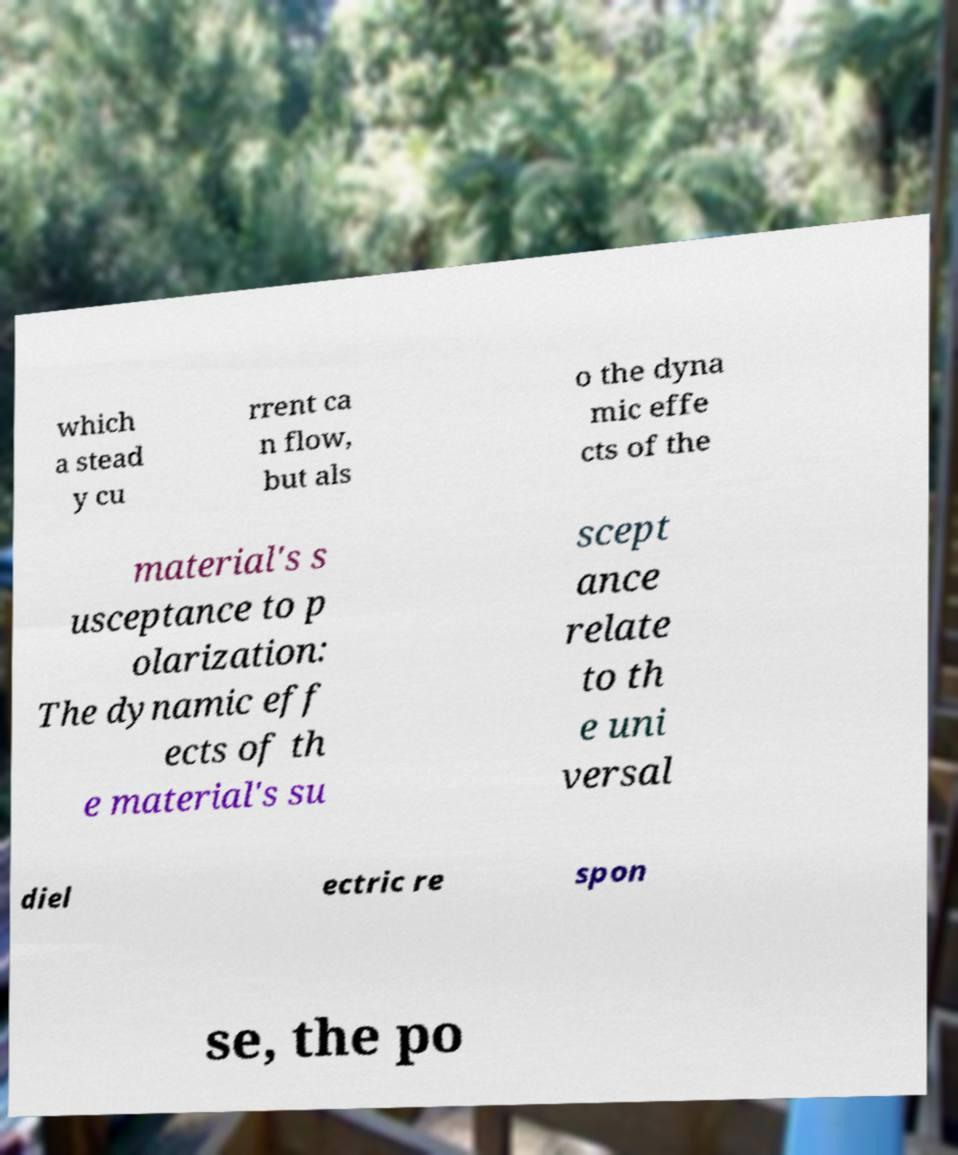Could you extract and type out the text from this image? which a stead y cu rrent ca n flow, but als o the dyna mic effe cts of the material's s usceptance to p olarization: The dynamic eff ects of th e material's su scept ance relate to th e uni versal diel ectric re spon se, the po 